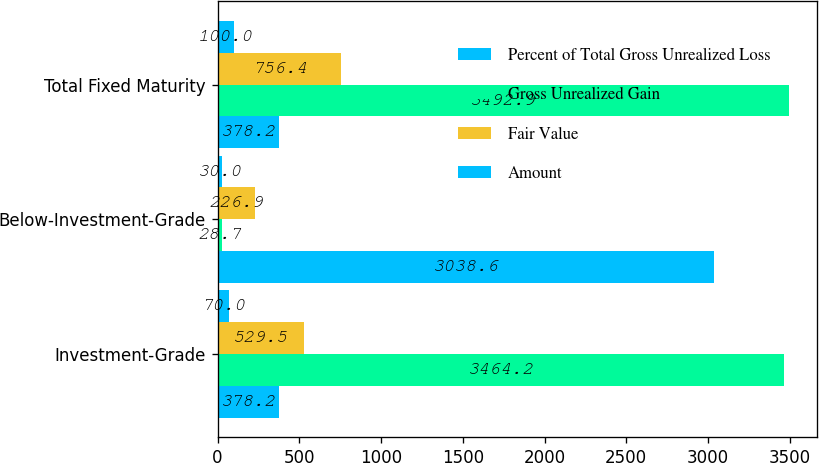Convert chart. <chart><loc_0><loc_0><loc_500><loc_500><stacked_bar_chart><ecel><fcel>Investment-Grade<fcel>Below-Investment-Grade<fcel>Total Fixed Maturity<nl><fcel>Percent of Total Gross Unrealized Loss<fcel>378.2<fcel>3038.6<fcel>378.2<nl><fcel>Gross Unrealized Gain<fcel>3464.2<fcel>28.7<fcel>3492.9<nl><fcel>Fair Value<fcel>529.5<fcel>226.9<fcel>756.4<nl><fcel>Amount<fcel>70<fcel>30<fcel>100<nl></chart> 